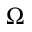Convert formula to latex. <formula><loc_0><loc_0><loc_500><loc_500>\Omega</formula> 